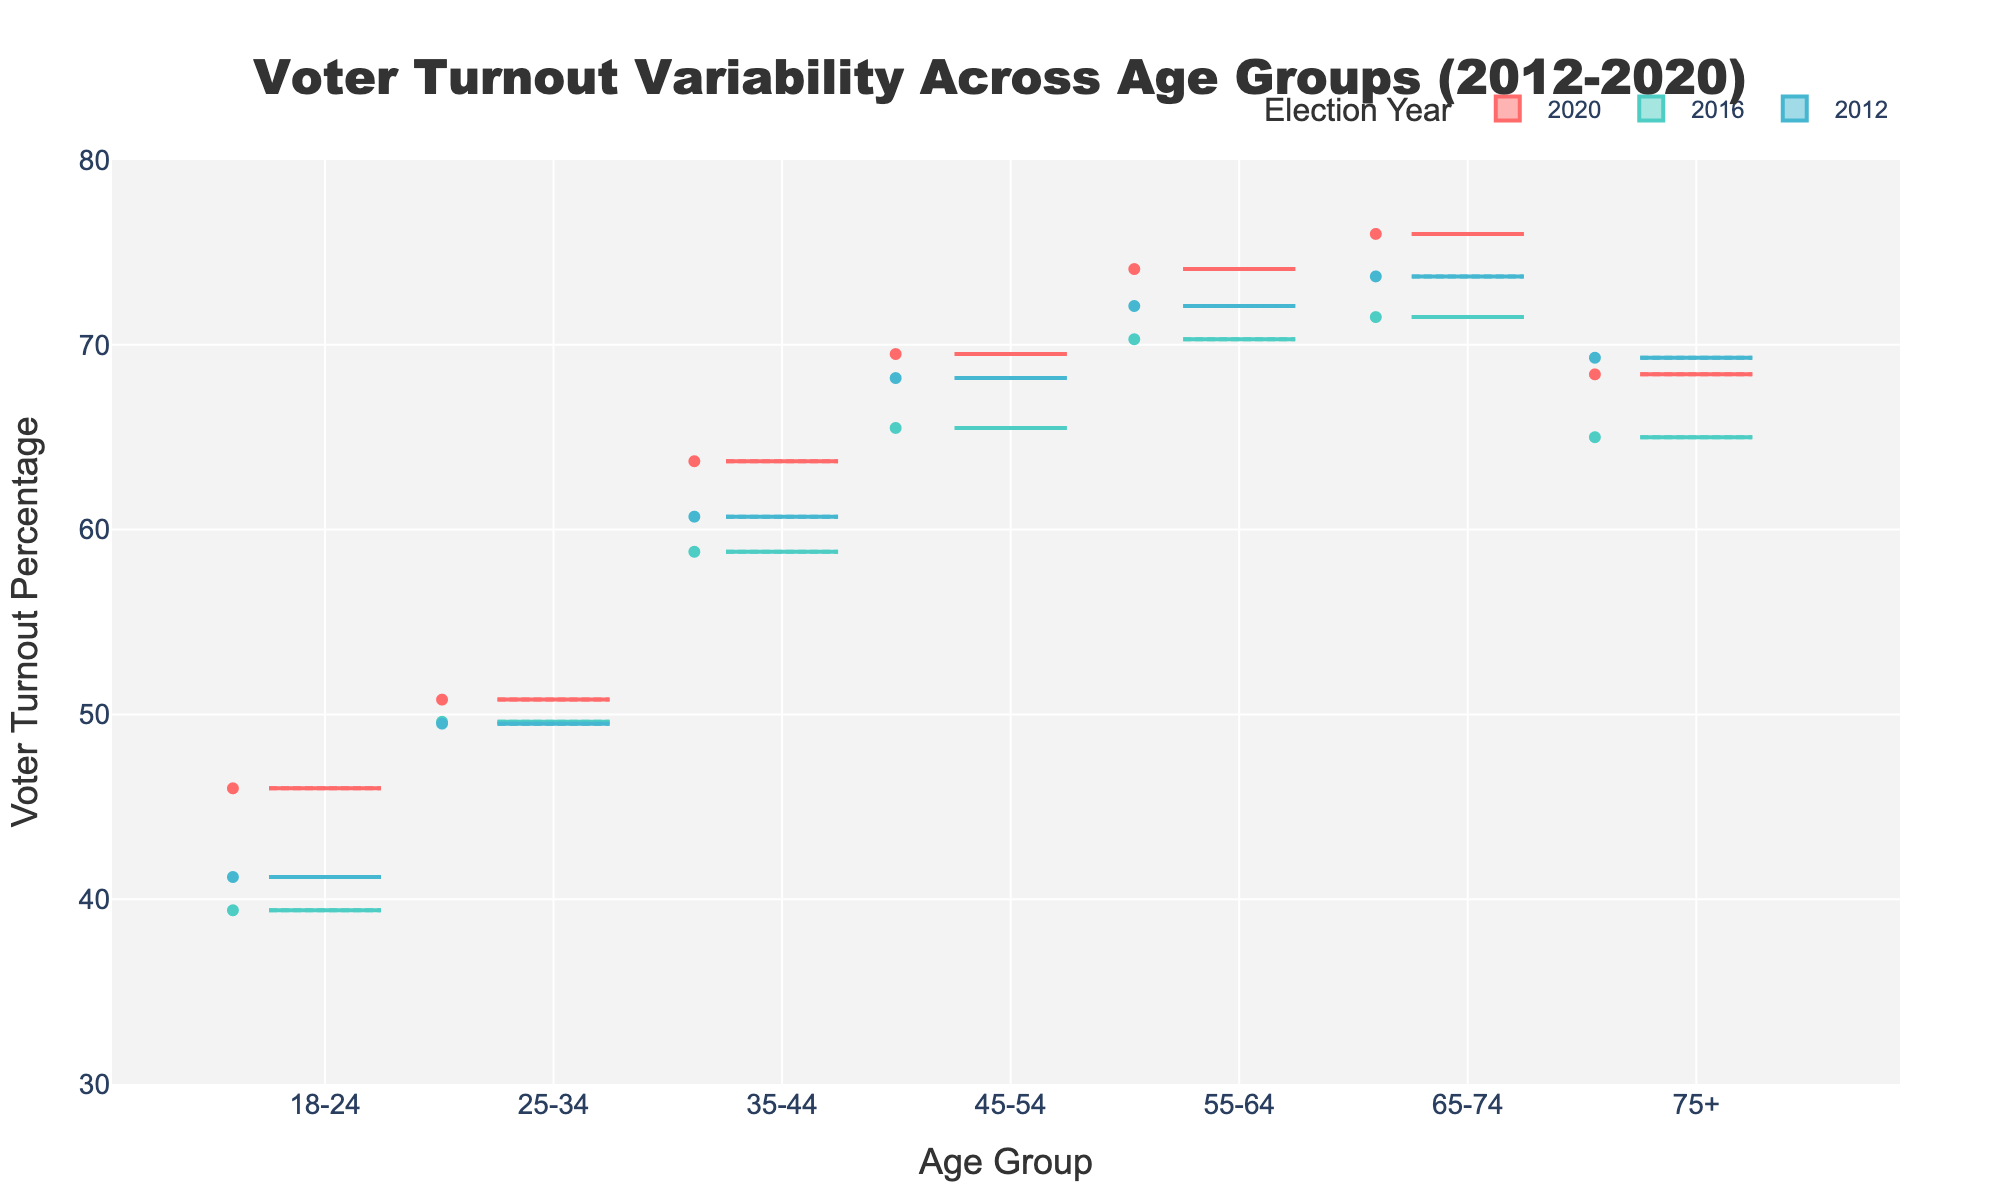what is the title of the figure? The title is located at the top center of the plot and is displayed in a larger, bold font.
Answer: Voter Turnout Variability Across Age Groups (2012-2020) what is the percentage range of voter turnout shown on the y-axis? The range of the y-axis is from 30% to 80% as indicated by the axis markers.
Answer: 30% to 80% which age group had the highest voter turnout percentage in the 2020 election? Looking at the 2020 notched box plot traces, the age group 65-74 has the highest median voter turnout.
Answer: 65-74 how does the voter turnout median for the age group 25-34 in 2020 compare to that in 2016? By comparing the notched box plots for the age group 25-34 in 2020 and 2016, the median turnout in 2020 is higher than in 2016.
Answer: higher in 2020 is there any overlap in the voter turnout percentages between the age groups 45-54 and 55-64 in the 2012 election? Checking the notch regions for the box plots of 45-54 and 55-64 in 2012, there is no overlap between the two groups, indicating significant differences.
Answer: no overlap which election year shows the widest variability in voter turnout for the age group 18-24? The width of the notched box plot for the 18-24 age group is widest in the 2016 election year, suggesting more variability in that year.
Answer: 2016 how does the voter turnout for the age group 75+ in 2016 compare to 2020? Comparing the notched box plots for the age group 75+ in 2016 and 2020, the median value in 2020 is higher than in 2016.
Answer: higher in 2020 how does the voter turnout percentage change for the age group 55-64 from 2012 to 2020? Observation of the notched box plots for the age group 55-64 shows a steady increase in median voter turnout from 2012 to 2020.
Answer: steady increase which election year has the least variability in voter turnout across all age groups? By examining the width of the notched regions for all age groups, the 2020 election year shows the least variability in voter turnout.
Answer: 2020 